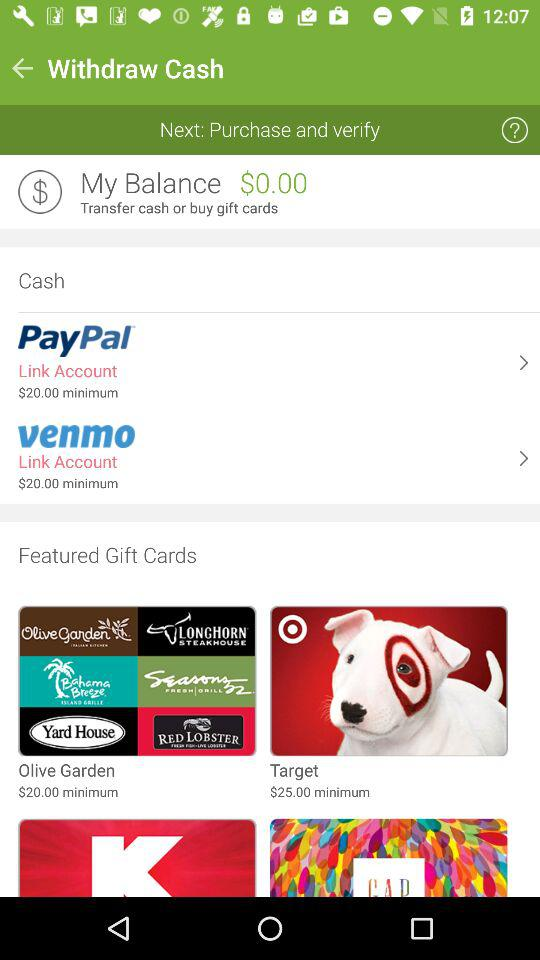What is the minimum balance to link the "PayPal" account? The minimum balance is $20. 